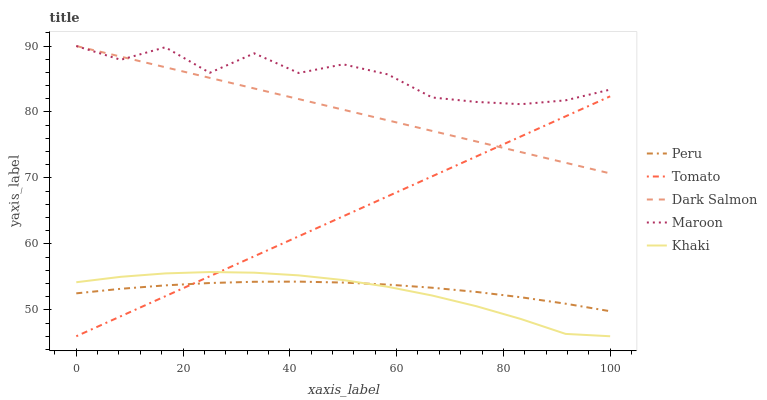Does Maroon have the minimum area under the curve?
Answer yes or no. No. Does Khaki have the maximum area under the curve?
Answer yes or no. No. Is Khaki the smoothest?
Answer yes or no. No. Is Khaki the roughest?
Answer yes or no. No. Does Maroon have the lowest value?
Answer yes or no. No. Does Khaki have the highest value?
Answer yes or no. No. Is Khaki less than Dark Salmon?
Answer yes or no. Yes. Is Maroon greater than Khaki?
Answer yes or no. Yes. Does Khaki intersect Dark Salmon?
Answer yes or no. No. 